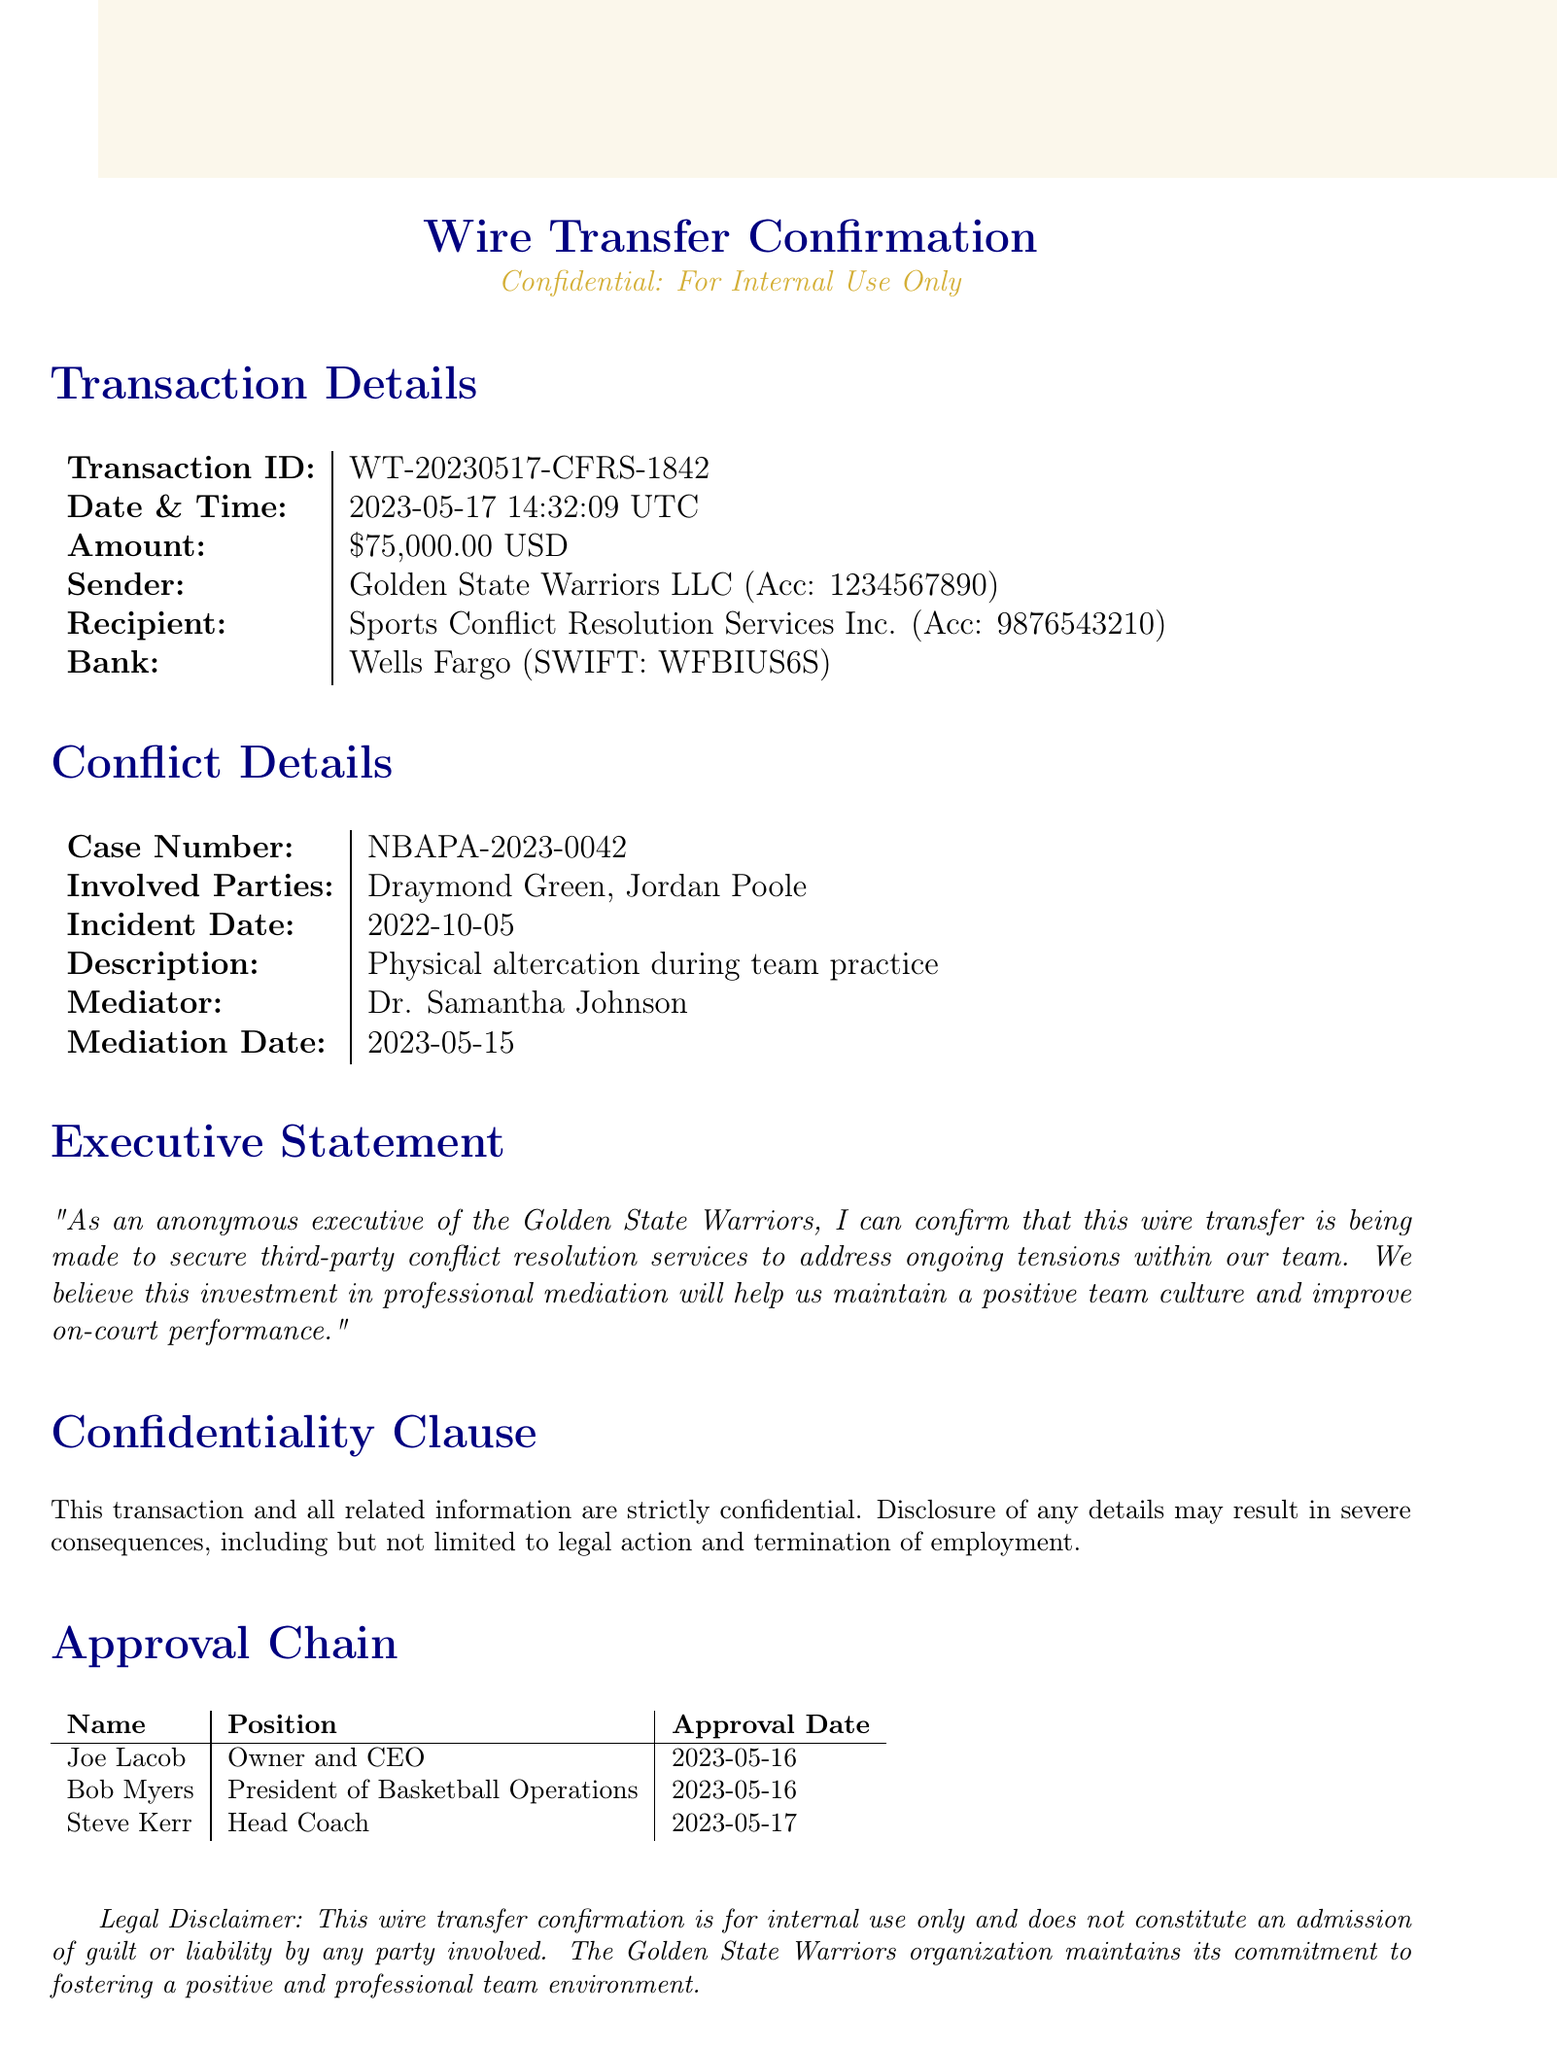What is the transaction ID? The transaction ID is specifically listed in the document, as "WT-20230517-CFRS-1842".
Answer: WT-20230517-CFRS-1842 What is the amount of the wire transfer? The amount is clearly stated in the transaction details as "$75,000.00".
Answer: $75,000.00 Who is the sender of the transfer? The sender is mentioned in the document as "Golden State Warriors LLC".
Answer: Golden State Warriors LLC What is the incident date related to the conflict? The incident date for the conflict is provided in the document as "2022-10-05".
Answer: 2022-10-05 Which bank processed the wire transfer? The bank involved in the wire transfer is listed as "Wells Fargo".
Answer: Wells Fargo What is the purpose of the wire transfer? The purpose is addressed in the executive statement, indicating that it is for "third-party conflict resolution services".
Answer: third-party conflict resolution services How many approvals were needed for this transaction? There are three individuals listed in the approval chain, indicating the number of approvals.
Answer: 3 Who was the mediator for the conflict? The document states that the mediator's name is "Dr. Samantha Johnson".
Answer: Dr. Samantha Johnson What is the confidentiality clause in the document? The confidentiality clause states that "This transaction and all related information are strictly confidential."
Answer: This transaction and all related information are strictly confidential 